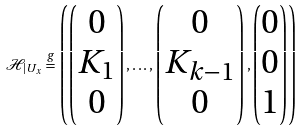Convert formula to latex. <formula><loc_0><loc_0><loc_500><loc_500>\mathcal { H } _ { | U _ { x } } \stackrel { g } { = } \left ( \begin{pmatrix} 0 \\ K _ { 1 } \\ 0 \end{pmatrix} , \dots , \begin{pmatrix} 0 \\ K _ { k - 1 } \\ 0 \end{pmatrix} , \begin{pmatrix} 0 \\ 0 \\ 1 \end{pmatrix} \right )</formula> 